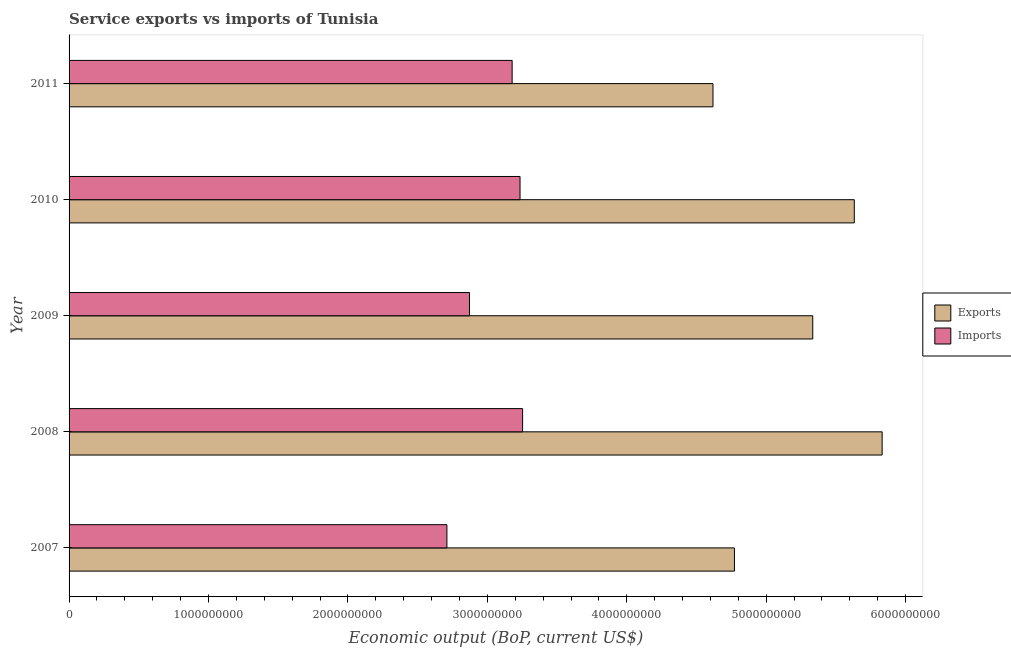How many different coloured bars are there?
Ensure brevity in your answer.  2. How many groups of bars are there?
Your answer should be compact. 5. Are the number of bars on each tick of the Y-axis equal?
Your response must be concise. Yes. What is the label of the 2nd group of bars from the top?
Give a very brief answer. 2010. In how many cases, is the number of bars for a given year not equal to the number of legend labels?
Give a very brief answer. 0. What is the amount of service imports in 2007?
Provide a short and direct response. 2.71e+09. Across all years, what is the maximum amount of service imports?
Offer a terse response. 3.25e+09. Across all years, what is the minimum amount of service imports?
Keep it short and to the point. 2.71e+09. In which year was the amount of service imports maximum?
Provide a short and direct response. 2008. What is the total amount of service exports in the graph?
Your answer should be compact. 2.62e+1. What is the difference between the amount of service imports in 2009 and that in 2010?
Provide a short and direct response. -3.62e+08. What is the difference between the amount of service exports in 2009 and the amount of service imports in 2007?
Provide a short and direct response. 2.62e+09. What is the average amount of service exports per year?
Ensure brevity in your answer.  5.24e+09. In the year 2011, what is the difference between the amount of service exports and amount of service imports?
Provide a succinct answer. 1.44e+09. What is the ratio of the amount of service exports in 2008 to that in 2010?
Offer a terse response. 1.03. Is the difference between the amount of service imports in 2008 and 2010 greater than the difference between the amount of service exports in 2008 and 2010?
Offer a terse response. No. What is the difference between the highest and the second highest amount of service exports?
Make the answer very short. 2.00e+08. What is the difference between the highest and the lowest amount of service exports?
Give a very brief answer. 1.21e+09. In how many years, is the amount of service imports greater than the average amount of service imports taken over all years?
Offer a terse response. 3. What does the 1st bar from the top in 2008 represents?
Make the answer very short. Imports. What does the 1st bar from the bottom in 2008 represents?
Your answer should be very brief. Exports. Are all the bars in the graph horizontal?
Provide a succinct answer. Yes. How many years are there in the graph?
Your answer should be very brief. 5. What is the difference between two consecutive major ticks on the X-axis?
Provide a short and direct response. 1.00e+09. Does the graph contain any zero values?
Make the answer very short. No. Where does the legend appear in the graph?
Your answer should be very brief. Center right. What is the title of the graph?
Ensure brevity in your answer.  Service exports vs imports of Tunisia. What is the label or title of the X-axis?
Offer a terse response. Economic output (BoP, current US$). What is the label or title of the Y-axis?
Make the answer very short. Year. What is the Economic output (BoP, current US$) in Exports in 2007?
Ensure brevity in your answer.  4.77e+09. What is the Economic output (BoP, current US$) of Imports in 2007?
Your answer should be compact. 2.71e+09. What is the Economic output (BoP, current US$) in Exports in 2008?
Keep it short and to the point. 5.83e+09. What is the Economic output (BoP, current US$) in Imports in 2008?
Make the answer very short. 3.25e+09. What is the Economic output (BoP, current US$) in Exports in 2009?
Provide a short and direct response. 5.33e+09. What is the Economic output (BoP, current US$) of Imports in 2009?
Offer a very short reply. 2.87e+09. What is the Economic output (BoP, current US$) in Exports in 2010?
Your response must be concise. 5.63e+09. What is the Economic output (BoP, current US$) of Imports in 2010?
Make the answer very short. 3.23e+09. What is the Economic output (BoP, current US$) of Exports in 2011?
Keep it short and to the point. 4.62e+09. What is the Economic output (BoP, current US$) of Imports in 2011?
Offer a terse response. 3.18e+09. Across all years, what is the maximum Economic output (BoP, current US$) in Exports?
Give a very brief answer. 5.83e+09. Across all years, what is the maximum Economic output (BoP, current US$) in Imports?
Make the answer very short. 3.25e+09. Across all years, what is the minimum Economic output (BoP, current US$) in Exports?
Make the answer very short. 4.62e+09. Across all years, what is the minimum Economic output (BoP, current US$) of Imports?
Your answer should be compact. 2.71e+09. What is the total Economic output (BoP, current US$) in Exports in the graph?
Your answer should be compact. 2.62e+1. What is the total Economic output (BoP, current US$) of Imports in the graph?
Offer a terse response. 1.52e+1. What is the difference between the Economic output (BoP, current US$) in Exports in 2007 and that in 2008?
Keep it short and to the point. -1.06e+09. What is the difference between the Economic output (BoP, current US$) in Imports in 2007 and that in 2008?
Keep it short and to the point. -5.43e+08. What is the difference between the Economic output (BoP, current US$) in Exports in 2007 and that in 2009?
Give a very brief answer. -5.62e+08. What is the difference between the Economic output (BoP, current US$) of Imports in 2007 and that in 2009?
Provide a short and direct response. -1.62e+08. What is the difference between the Economic output (BoP, current US$) of Exports in 2007 and that in 2010?
Your answer should be compact. -8.60e+08. What is the difference between the Economic output (BoP, current US$) of Imports in 2007 and that in 2010?
Your response must be concise. -5.24e+08. What is the difference between the Economic output (BoP, current US$) in Exports in 2007 and that in 2011?
Keep it short and to the point. 1.54e+08. What is the difference between the Economic output (BoP, current US$) in Imports in 2007 and that in 2011?
Your answer should be very brief. -4.68e+08. What is the difference between the Economic output (BoP, current US$) in Exports in 2008 and that in 2009?
Make the answer very short. 4.98e+08. What is the difference between the Economic output (BoP, current US$) of Imports in 2008 and that in 2009?
Offer a very short reply. 3.81e+08. What is the difference between the Economic output (BoP, current US$) of Exports in 2008 and that in 2010?
Your answer should be compact. 2.00e+08. What is the difference between the Economic output (BoP, current US$) in Imports in 2008 and that in 2010?
Give a very brief answer. 1.84e+07. What is the difference between the Economic output (BoP, current US$) of Exports in 2008 and that in 2011?
Keep it short and to the point. 1.21e+09. What is the difference between the Economic output (BoP, current US$) of Imports in 2008 and that in 2011?
Ensure brevity in your answer.  7.50e+07. What is the difference between the Economic output (BoP, current US$) of Exports in 2009 and that in 2010?
Provide a short and direct response. -2.98e+08. What is the difference between the Economic output (BoP, current US$) of Imports in 2009 and that in 2010?
Provide a short and direct response. -3.62e+08. What is the difference between the Economic output (BoP, current US$) in Exports in 2009 and that in 2011?
Provide a succinct answer. 7.16e+08. What is the difference between the Economic output (BoP, current US$) in Imports in 2009 and that in 2011?
Your answer should be compact. -3.06e+08. What is the difference between the Economic output (BoP, current US$) in Exports in 2010 and that in 2011?
Offer a terse response. 1.01e+09. What is the difference between the Economic output (BoP, current US$) of Imports in 2010 and that in 2011?
Ensure brevity in your answer.  5.66e+07. What is the difference between the Economic output (BoP, current US$) in Exports in 2007 and the Economic output (BoP, current US$) in Imports in 2008?
Give a very brief answer. 1.52e+09. What is the difference between the Economic output (BoP, current US$) in Exports in 2007 and the Economic output (BoP, current US$) in Imports in 2009?
Keep it short and to the point. 1.90e+09. What is the difference between the Economic output (BoP, current US$) in Exports in 2007 and the Economic output (BoP, current US$) in Imports in 2010?
Provide a succinct answer. 1.54e+09. What is the difference between the Economic output (BoP, current US$) in Exports in 2007 and the Economic output (BoP, current US$) in Imports in 2011?
Offer a very short reply. 1.59e+09. What is the difference between the Economic output (BoP, current US$) of Exports in 2008 and the Economic output (BoP, current US$) of Imports in 2009?
Ensure brevity in your answer.  2.96e+09. What is the difference between the Economic output (BoP, current US$) of Exports in 2008 and the Economic output (BoP, current US$) of Imports in 2010?
Your answer should be compact. 2.60e+09. What is the difference between the Economic output (BoP, current US$) of Exports in 2008 and the Economic output (BoP, current US$) of Imports in 2011?
Your answer should be very brief. 2.65e+09. What is the difference between the Economic output (BoP, current US$) of Exports in 2009 and the Economic output (BoP, current US$) of Imports in 2010?
Ensure brevity in your answer.  2.10e+09. What is the difference between the Economic output (BoP, current US$) in Exports in 2009 and the Economic output (BoP, current US$) in Imports in 2011?
Ensure brevity in your answer.  2.16e+09. What is the difference between the Economic output (BoP, current US$) of Exports in 2010 and the Economic output (BoP, current US$) of Imports in 2011?
Offer a very short reply. 2.45e+09. What is the average Economic output (BoP, current US$) of Exports per year?
Provide a succinct answer. 5.24e+09. What is the average Economic output (BoP, current US$) of Imports per year?
Offer a very short reply. 3.05e+09. In the year 2007, what is the difference between the Economic output (BoP, current US$) in Exports and Economic output (BoP, current US$) in Imports?
Offer a very short reply. 2.06e+09. In the year 2008, what is the difference between the Economic output (BoP, current US$) of Exports and Economic output (BoP, current US$) of Imports?
Offer a very short reply. 2.58e+09. In the year 2009, what is the difference between the Economic output (BoP, current US$) of Exports and Economic output (BoP, current US$) of Imports?
Ensure brevity in your answer.  2.46e+09. In the year 2010, what is the difference between the Economic output (BoP, current US$) of Exports and Economic output (BoP, current US$) of Imports?
Offer a very short reply. 2.40e+09. In the year 2011, what is the difference between the Economic output (BoP, current US$) of Exports and Economic output (BoP, current US$) of Imports?
Offer a terse response. 1.44e+09. What is the ratio of the Economic output (BoP, current US$) of Exports in 2007 to that in 2008?
Keep it short and to the point. 0.82. What is the ratio of the Economic output (BoP, current US$) of Imports in 2007 to that in 2008?
Give a very brief answer. 0.83. What is the ratio of the Economic output (BoP, current US$) in Exports in 2007 to that in 2009?
Ensure brevity in your answer.  0.89. What is the ratio of the Economic output (BoP, current US$) in Imports in 2007 to that in 2009?
Provide a short and direct response. 0.94. What is the ratio of the Economic output (BoP, current US$) of Exports in 2007 to that in 2010?
Keep it short and to the point. 0.85. What is the ratio of the Economic output (BoP, current US$) of Imports in 2007 to that in 2010?
Keep it short and to the point. 0.84. What is the ratio of the Economic output (BoP, current US$) of Imports in 2007 to that in 2011?
Offer a terse response. 0.85. What is the ratio of the Economic output (BoP, current US$) of Exports in 2008 to that in 2009?
Your answer should be compact. 1.09. What is the ratio of the Economic output (BoP, current US$) of Imports in 2008 to that in 2009?
Make the answer very short. 1.13. What is the ratio of the Economic output (BoP, current US$) in Exports in 2008 to that in 2010?
Provide a succinct answer. 1.04. What is the ratio of the Economic output (BoP, current US$) in Imports in 2008 to that in 2010?
Ensure brevity in your answer.  1.01. What is the ratio of the Economic output (BoP, current US$) of Exports in 2008 to that in 2011?
Your response must be concise. 1.26. What is the ratio of the Economic output (BoP, current US$) in Imports in 2008 to that in 2011?
Ensure brevity in your answer.  1.02. What is the ratio of the Economic output (BoP, current US$) in Exports in 2009 to that in 2010?
Your response must be concise. 0.95. What is the ratio of the Economic output (BoP, current US$) of Imports in 2009 to that in 2010?
Offer a terse response. 0.89. What is the ratio of the Economic output (BoP, current US$) in Exports in 2009 to that in 2011?
Your answer should be very brief. 1.15. What is the ratio of the Economic output (BoP, current US$) in Imports in 2009 to that in 2011?
Provide a short and direct response. 0.9. What is the ratio of the Economic output (BoP, current US$) in Exports in 2010 to that in 2011?
Your response must be concise. 1.22. What is the ratio of the Economic output (BoP, current US$) of Imports in 2010 to that in 2011?
Your answer should be very brief. 1.02. What is the difference between the highest and the second highest Economic output (BoP, current US$) in Exports?
Your answer should be compact. 2.00e+08. What is the difference between the highest and the second highest Economic output (BoP, current US$) in Imports?
Offer a very short reply. 1.84e+07. What is the difference between the highest and the lowest Economic output (BoP, current US$) in Exports?
Your answer should be compact. 1.21e+09. What is the difference between the highest and the lowest Economic output (BoP, current US$) of Imports?
Offer a terse response. 5.43e+08. 